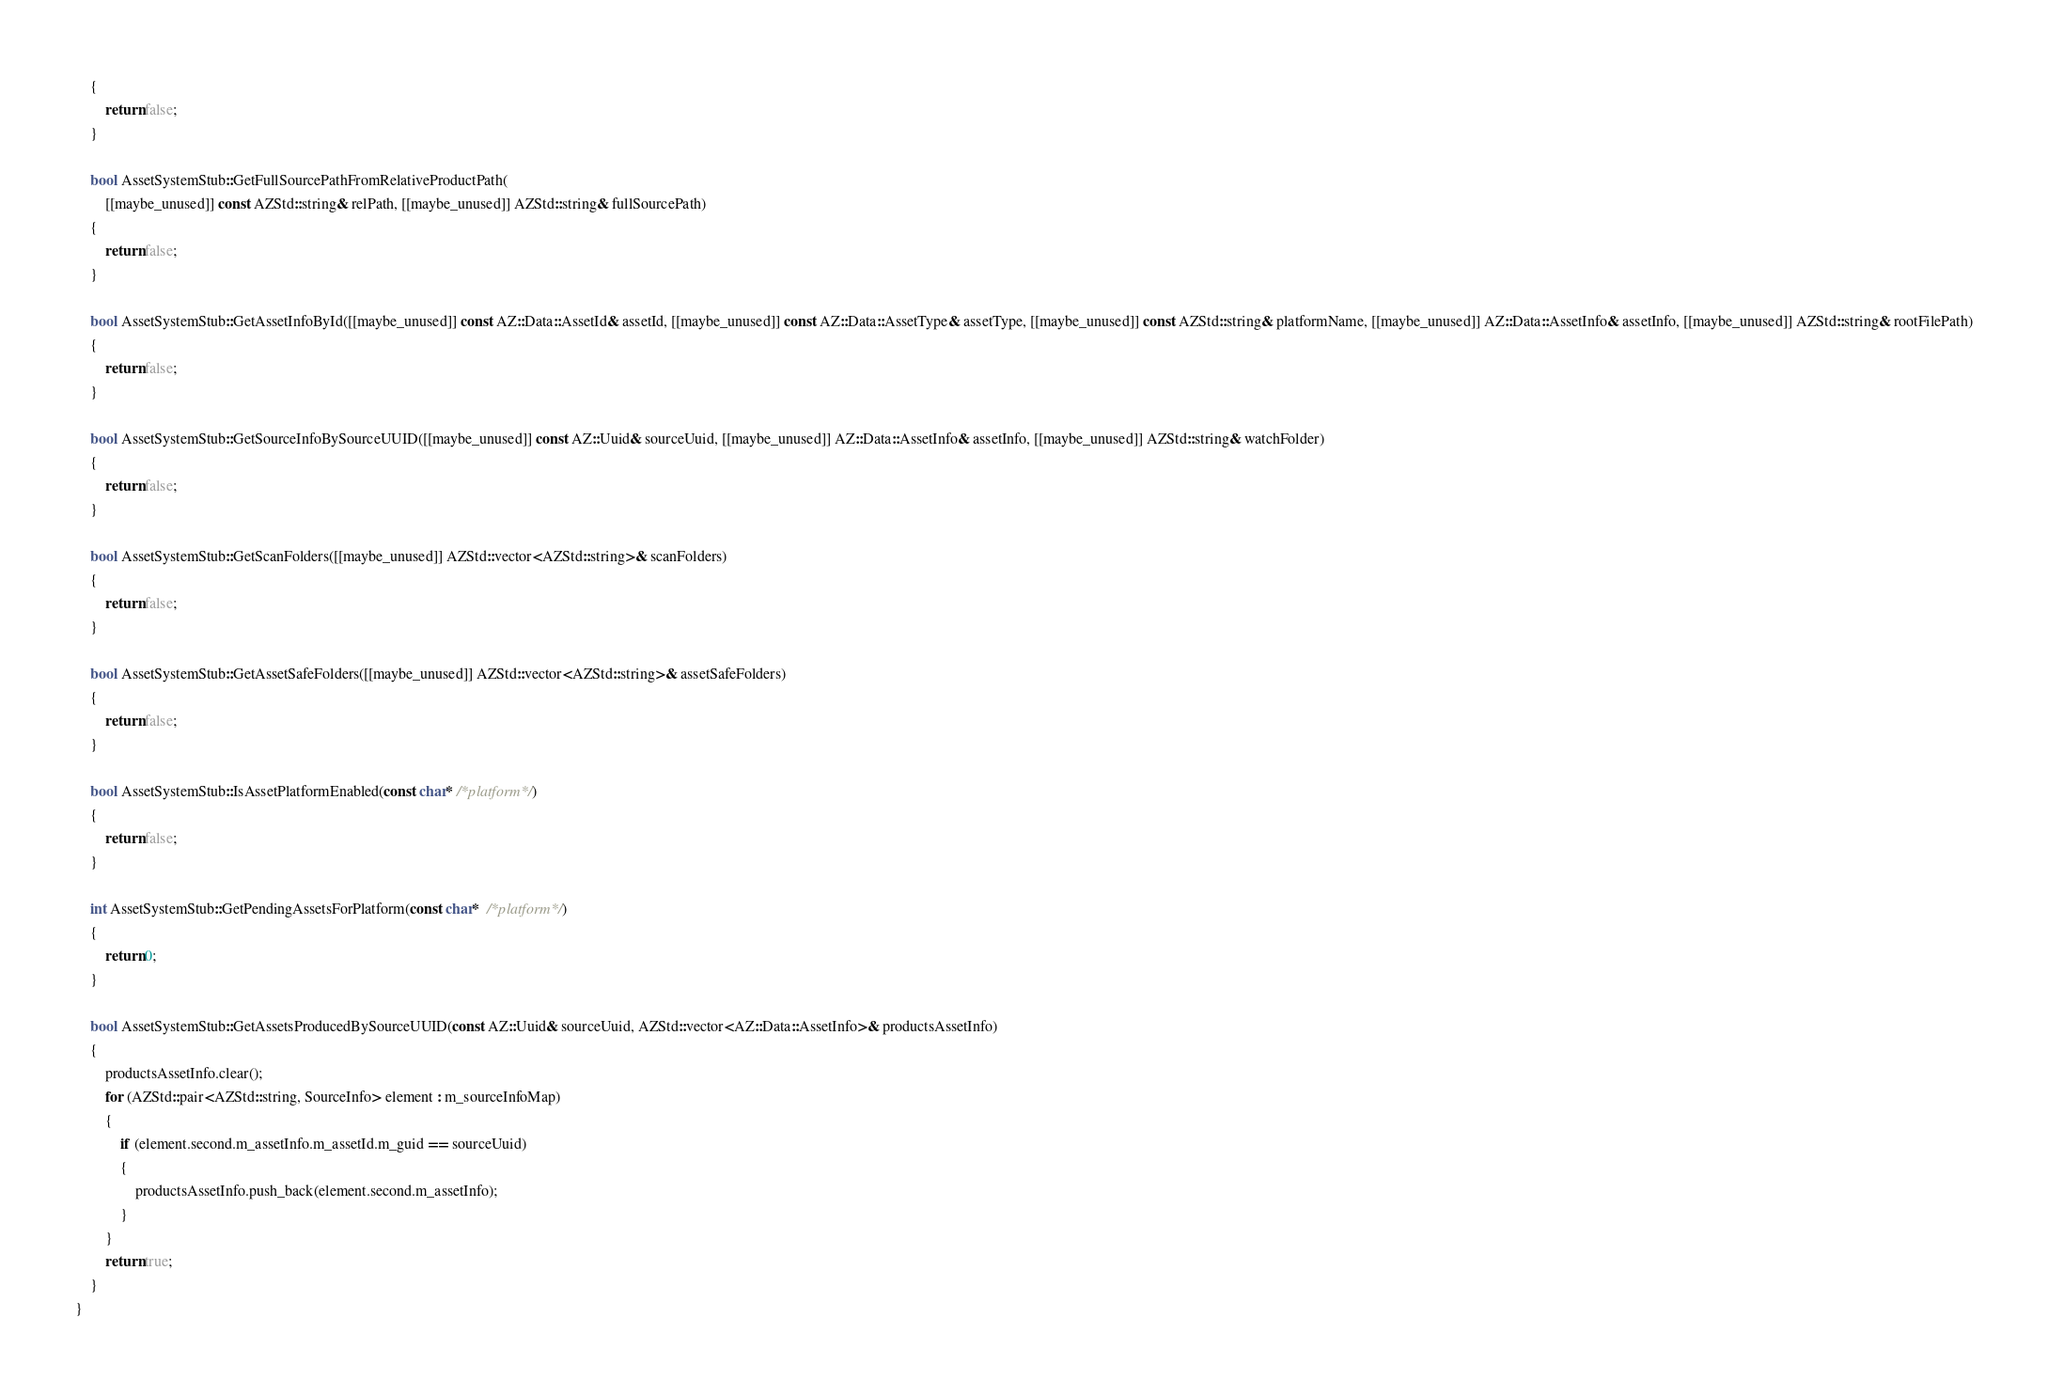Convert code to text. <code><loc_0><loc_0><loc_500><loc_500><_C++_>    {
        return false;
    }

    bool AssetSystemStub::GetFullSourcePathFromRelativeProductPath(
        [[maybe_unused]] const AZStd::string& relPath, [[maybe_unused]] AZStd::string& fullSourcePath)
    {
        return false;
    }

    bool AssetSystemStub::GetAssetInfoById([[maybe_unused]] const AZ::Data::AssetId& assetId, [[maybe_unused]] const AZ::Data::AssetType& assetType, [[maybe_unused]] const AZStd::string& platformName, [[maybe_unused]] AZ::Data::AssetInfo& assetInfo, [[maybe_unused]] AZStd::string& rootFilePath)
    {
        return false;
    }

    bool AssetSystemStub::GetSourceInfoBySourceUUID([[maybe_unused]] const AZ::Uuid& sourceUuid, [[maybe_unused]] AZ::Data::AssetInfo& assetInfo, [[maybe_unused]] AZStd::string& watchFolder)
    {
        return false;
    }

    bool AssetSystemStub::GetScanFolders([[maybe_unused]] AZStd::vector<AZStd::string>& scanFolders)
    {
        return false;
    }

    bool AssetSystemStub::GetAssetSafeFolders([[maybe_unused]] AZStd::vector<AZStd::string>& assetSafeFolders)
    {
        return false;
    }

    bool AssetSystemStub::IsAssetPlatformEnabled(const char* /*platform*/)
    {
        return false;
    }

    int AssetSystemStub::GetPendingAssetsForPlatform(const char*  /*platform*/)
    {
        return 0;
    }

    bool AssetSystemStub::GetAssetsProducedBySourceUUID(const AZ::Uuid& sourceUuid, AZStd::vector<AZ::Data::AssetInfo>& productsAssetInfo)
    {
        productsAssetInfo.clear();
        for (AZStd::pair<AZStd::string, SourceInfo> element : m_sourceInfoMap)
        {
            if (element.second.m_assetInfo.m_assetId.m_guid == sourceUuid)
            {
                productsAssetInfo.push_back(element.second.m_assetInfo);
            }
        }
        return true;
    }
}
</code> 